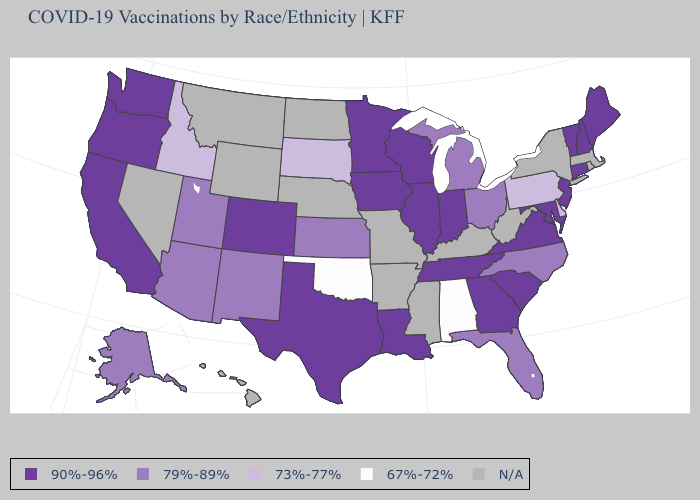Name the states that have a value in the range N/A?
Be succinct. Arkansas, Hawaii, Kentucky, Massachusetts, Mississippi, Missouri, Montana, Nebraska, Nevada, New York, North Dakota, Rhode Island, West Virginia, Wyoming. Does the map have missing data?
Quick response, please. Yes. Does Alabama have the lowest value in the USA?
Quick response, please. Yes. What is the value of Alaska?
Concise answer only. 79%-89%. What is the highest value in the South ?
Be succinct. 90%-96%. Does New Hampshire have the highest value in the Northeast?
Answer briefly. Yes. What is the highest value in states that border Alabama?
Be succinct. 90%-96%. What is the lowest value in states that border Mississippi?
Answer briefly. 67%-72%. Does Washington have the lowest value in the West?
Write a very short answer. No. What is the value of Louisiana?
Short answer required. 90%-96%. Does South Dakota have the lowest value in the MidWest?
Write a very short answer. Yes. Does Arizona have the highest value in the West?
Concise answer only. No. What is the value of Maine?
Concise answer only. 90%-96%. Does Michigan have the highest value in the MidWest?
Quick response, please. No. Which states have the highest value in the USA?
Give a very brief answer. California, Colorado, Connecticut, Georgia, Illinois, Indiana, Iowa, Louisiana, Maine, Maryland, Minnesota, New Hampshire, New Jersey, Oregon, South Carolina, Tennessee, Texas, Vermont, Virginia, Washington, Wisconsin. 